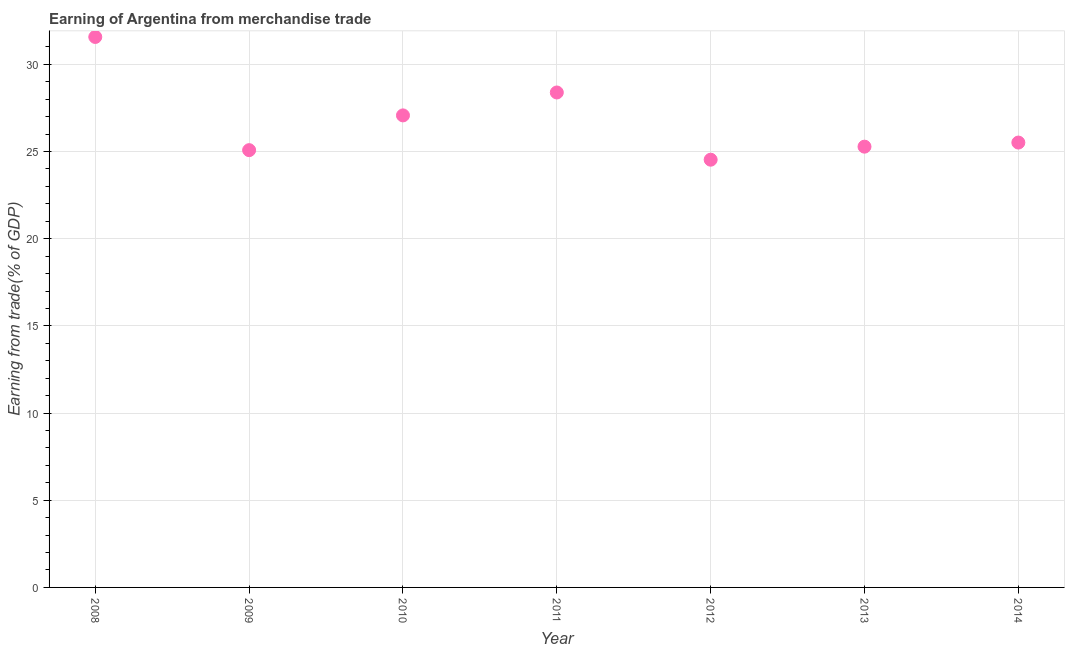What is the earning from merchandise trade in 2014?
Your answer should be very brief. 25.52. Across all years, what is the maximum earning from merchandise trade?
Give a very brief answer. 31.57. Across all years, what is the minimum earning from merchandise trade?
Your response must be concise. 24.53. In which year was the earning from merchandise trade maximum?
Your response must be concise. 2008. In which year was the earning from merchandise trade minimum?
Make the answer very short. 2012. What is the sum of the earning from merchandise trade?
Your answer should be compact. 187.44. What is the difference between the earning from merchandise trade in 2013 and 2014?
Your answer should be very brief. -0.24. What is the average earning from merchandise trade per year?
Offer a very short reply. 26.78. What is the median earning from merchandise trade?
Give a very brief answer. 25.52. Do a majority of the years between 2014 and 2013 (inclusive) have earning from merchandise trade greater than 21 %?
Offer a terse response. No. What is the ratio of the earning from merchandise trade in 2011 to that in 2012?
Your response must be concise. 1.16. Is the earning from merchandise trade in 2008 less than that in 2014?
Keep it short and to the point. No. What is the difference between the highest and the second highest earning from merchandise trade?
Your answer should be very brief. 3.18. Is the sum of the earning from merchandise trade in 2008 and 2009 greater than the maximum earning from merchandise trade across all years?
Your response must be concise. Yes. What is the difference between the highest and the lowest earning from merchandise trade?
Give a very brief answer. 7.04. Does the earning from merchandise trade monotonically increase over the years?
Provide a succinct answer. No. How many years are there in the graph?
Your answer should be very brief. 7. What is the difference between two consecutive major ticks on the Y-axis?
Your response must be concise. 5. Are the values on the major ticks of Y-axis written in scientific E-notation?
Ensure brevity in your answer.  No. What is the title of the graph?
Ensure brevity in your answer.  Earning of Argentina from merchandise trade. What is the label or title of the X-axis?
Offer a terse response. Year. What is the label or title of the Y-axis?
Ensure brevity in your answer.  Earning from trade(% of GDP). What is the Earning from trade(% of GDP) in 2008?
Offer a very short reply. 31.57. What is the Earning from trade(% of GDP) in 2009?
Give a very brief answer. 25.08. What is the Earning from trade(% of GDP) in 2010?
Your answer should be compact. 27.07. What is the Earning from trade(% of GDP) in 2011?
Provide a short and direct response. 28.39. What is the Earning from trade(% of GDP) in 2012?
Offer a terse response. 24.53. What is the Earning from trade(% of GDP) in 2013?
Your response must be concise. 25.28. What is the Earning from trade(% of GDP) in 2014?
Offer a very short reply. 25.52. What is the difference between the Earning from trade(% of GDP) in 2008 and 2009?
Keep it short and to the point. 6.49. What is the difference between the Earning from trade(% of GDP) in 2008 and 2010?
Provide a short and direct response. 4.5. What is the difference between the Earning from trade(% of GDP) in 2008 and 2011?
Make the answer very short. 3.18. What is the difference between the Earning from trade(% of GDP) in 2008 and 2012?
Your answer should be compact. 7.04. What is the difference between the Earning from trade(% of GDP) in 2008 and 2013?
Keep it short and to the point. 6.29. What is the difference between the Earning from trade(% of GDP) in 2008 and 2014?
Offer a terse response. 6.06. What is the difference between the Earning from trade(% of GDP) in 2009 and 2010?
Ensure brevity in your answer.  -1.99. What is the difference between the Earning from trade(% of GDP) in 2009 and 2011?
Your answer should be very brief. -3.31. What is the difference between the Earning from trade(% of GDP) in 2009 and 2012?
Provide a short and direct response. 0.55. What is the difference between the Earning from trade(% of GDP) in 2009 and 2013?
Offer a terse response. -0.2. What is the difference between the Earning from trade(% of GDP) in 2009 and 2014?
Your answer should be very brief. -0.44. What is the difference between the Earning from trade(% of GDP) in 2010 and 2011?
Provide a short and direct response. -1.31. What is the difference between the Earning from trade(% of GDP) in 2010 and 2012?
Your response must be concise. 2.54. What is the difference between the Earning from trade(% of GDP) in 2010 and 2013?
Your answer should be compact. 1.79. What is the difference between the Earning from trade(% of GDP) in 2010 and 2014?
Offer a very short reply. 1.56. What is the difference between the Earning from trade(% of GDP) in 2011 and 2012?
Provide a succinct answer. 3.86. What is the difference between the Earning from trade(% of GDP) in 2011 and 2013?
Your response must be concise. 3.11. What is the difference between the Earning from trade(% of GDP) in 2011 and 2014?
Ensure brevity in your answer.  2.87. What is the difference between the Earning from trade(% of GDP) in 2012 and 2013?
Keep it short and to the point. -0.75. What is the difference between the Earning from trade(% of GDP) in 2012 and 2014?
Provide a succinct answer. -0.98. What is the difference between the Earning from trade(% of GDP) in 2013 and 2014?
Make the answer very short. -0.24. What is the ratio of the Earning from trade(% of GDP) in 2008 to that in 2009?
Ensure brevity in your answer.  1.26. What is the ratio of the Earning from trade(% of GDP) in 2008 to that in 2010?
Provide a succinct answer. 1.17. What is the ratio of the Earning from trade(% of GDP) in 2008 to that in 2011?
Ensure brevity in your answer.  1.11. What is the ratio of the Earning from trade(% of GDP) in 2008 to that in 2012?
Your answer should be very brief. 1.29. What is the ratio of the Earning from trade(% of GDP) in 2008 to that in 2013?
Provide a succinct answer. 1.25. What is the ratio of the Earning from trade(% of GDP) in 2008 to that in 2014?
Offer a terse response. 1.24. What is the ratio of the Earning from trade(% of GDP) in 2009 to that in 2010?
Your answer should be very brief. 0.93. What is the ratio of the Earning from trade(% of GDP) in 2009 to that in 2011?
Offer a terse response. 0.88. What is the ratio of the Earning from trade(% of GDP) in 2009 to that in 2012?
Your response must be concise. 1.02. What is the ratio of the Earning from trade(% of GDP) in 2009 to that in 2014?
Your response must be concise. 0.98. What is the ratio of the Earning from trade(% of GDP) in 2010 to that in 2011?
Keep it short and to the point. 0.95. What is the ratio of the Earning from trade(% of GDP) in 2010 to that in 2012?
Your response must be concise. 1.1. What is the ratio of the Earning from trade(% of GDP) in 2010 to that in 2013?
Make the answer very short. 1.07. What is the ratio of the Earning from trade(% of GDP) in 2010 to that in 2014?
Make the answer very short. 1.06. What is the ratio of the Earning from trade(% of GDP) in 2011 to that in 2012?
Offer a very short reply. 1.16. What is the ratio of the Earning from trade(% of GDP) in 2011 to that in 2013?
Your response must be concise. 1.12. What is the ratio of the Earning from trade(% of GDP) in 2011 to that in 2014?
Make the answer very short. 1.11. What is the ratio of the Earning from trade(% of GDP) in 2013 to that in 2014?
Give a very brief answer. 0.99. 